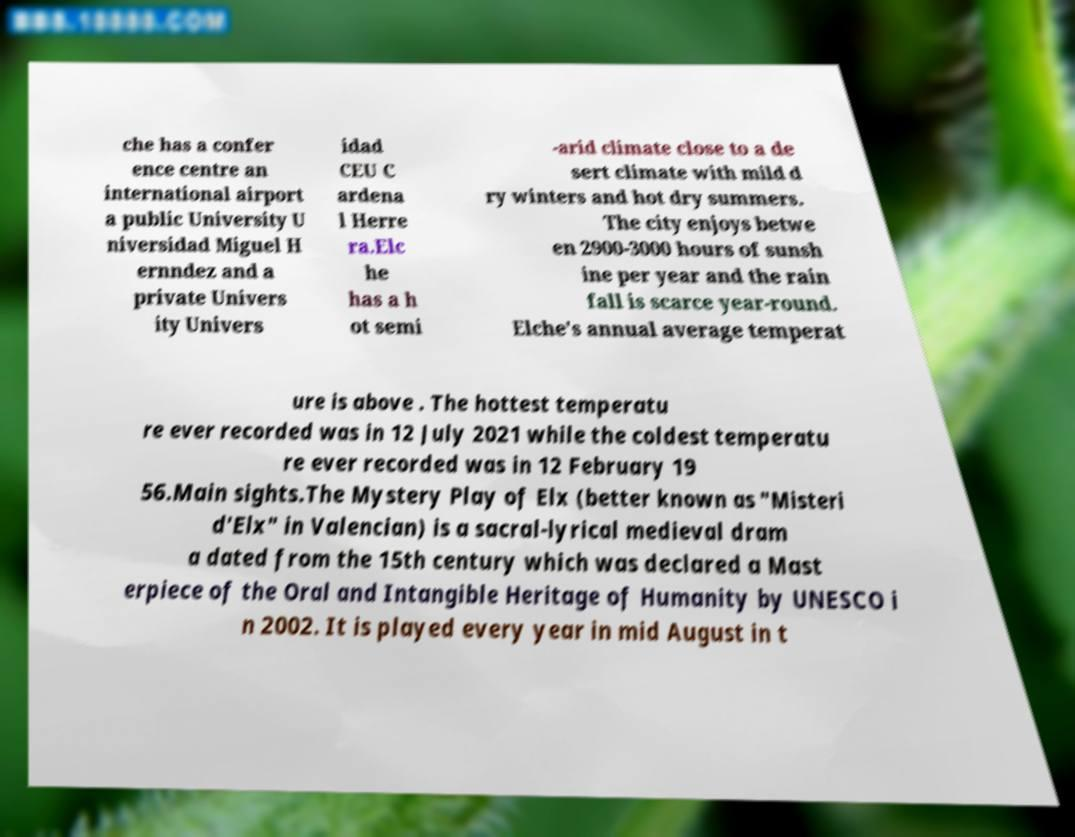What messages or text are displayed in this image? I need them in a readable, typed format. che has a confer ence centre an international airport a public University U niversidad Miguel H ernndez and a private Univers ity Univers idad CEU C ardena l Herre ra.Elc he has a h ot semi -arid climate close to a de sert climate with mild d ry winters and hot dry summers. The city enjoys betwe en 2900-3000 hours of sunsh ine per year and the rain fall is scarce year-round. Elche's annual average temperat ure is above . The hottest temperatu re ever recorded was in 12 July 2021 while the coldest temperatu re ever recorded was in 12 February 19 56.Main sights.The Mystery Play of Elx (better known as "Misteri d'Elx" in Valencian) is a sacral-lyrical medieval dram a dated from the 15th century which was declared a Mast erpiece of the Oral and Intangible Heritage of Humanity by UNESCO i n 2002. It is played every year in mid August in t 